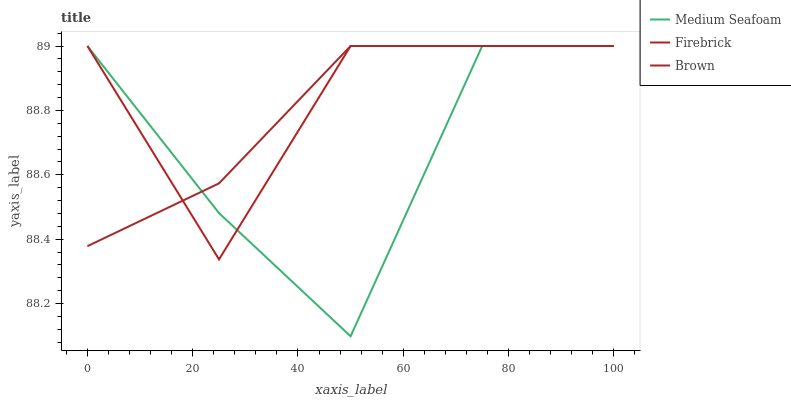Does Medium Seafoam have the minimum area under the curve?
Answer yes or no. Yes. Does Firebrick have the maximum area under the curve?
Answer yes or no. Yes. Does Firebrick have the minimum area under the curve?
Answer yes or no. No. Does Medium Seafoam have the maximum area under the curve?
Answer yes or no. No. Is Brown the smoothest?
Answer yes or no. Yes. Is Medium Seafoam the roughest?
Answer yes or no. Yes. Is Firebrick the smoothest?
Answer yes or no. No. Is Firebrick the roughest?
Answer yes or no. No. Does Medium Seafoam have the lowest value?
Answer yes or no. Yes. Does Firebrick have the lowest value?
Answer yes or no. No. Does Medium Seafoam have the highest value?
Answer yes or no. Yes. Does Brown intersect Medium Seafoam?
Answer yes or no. Yes. Is Brown less than Medium Seafoam?
Answer yes or no. No. Is Brown greater than Medium Seafoam?
Answer yes or no. No. 